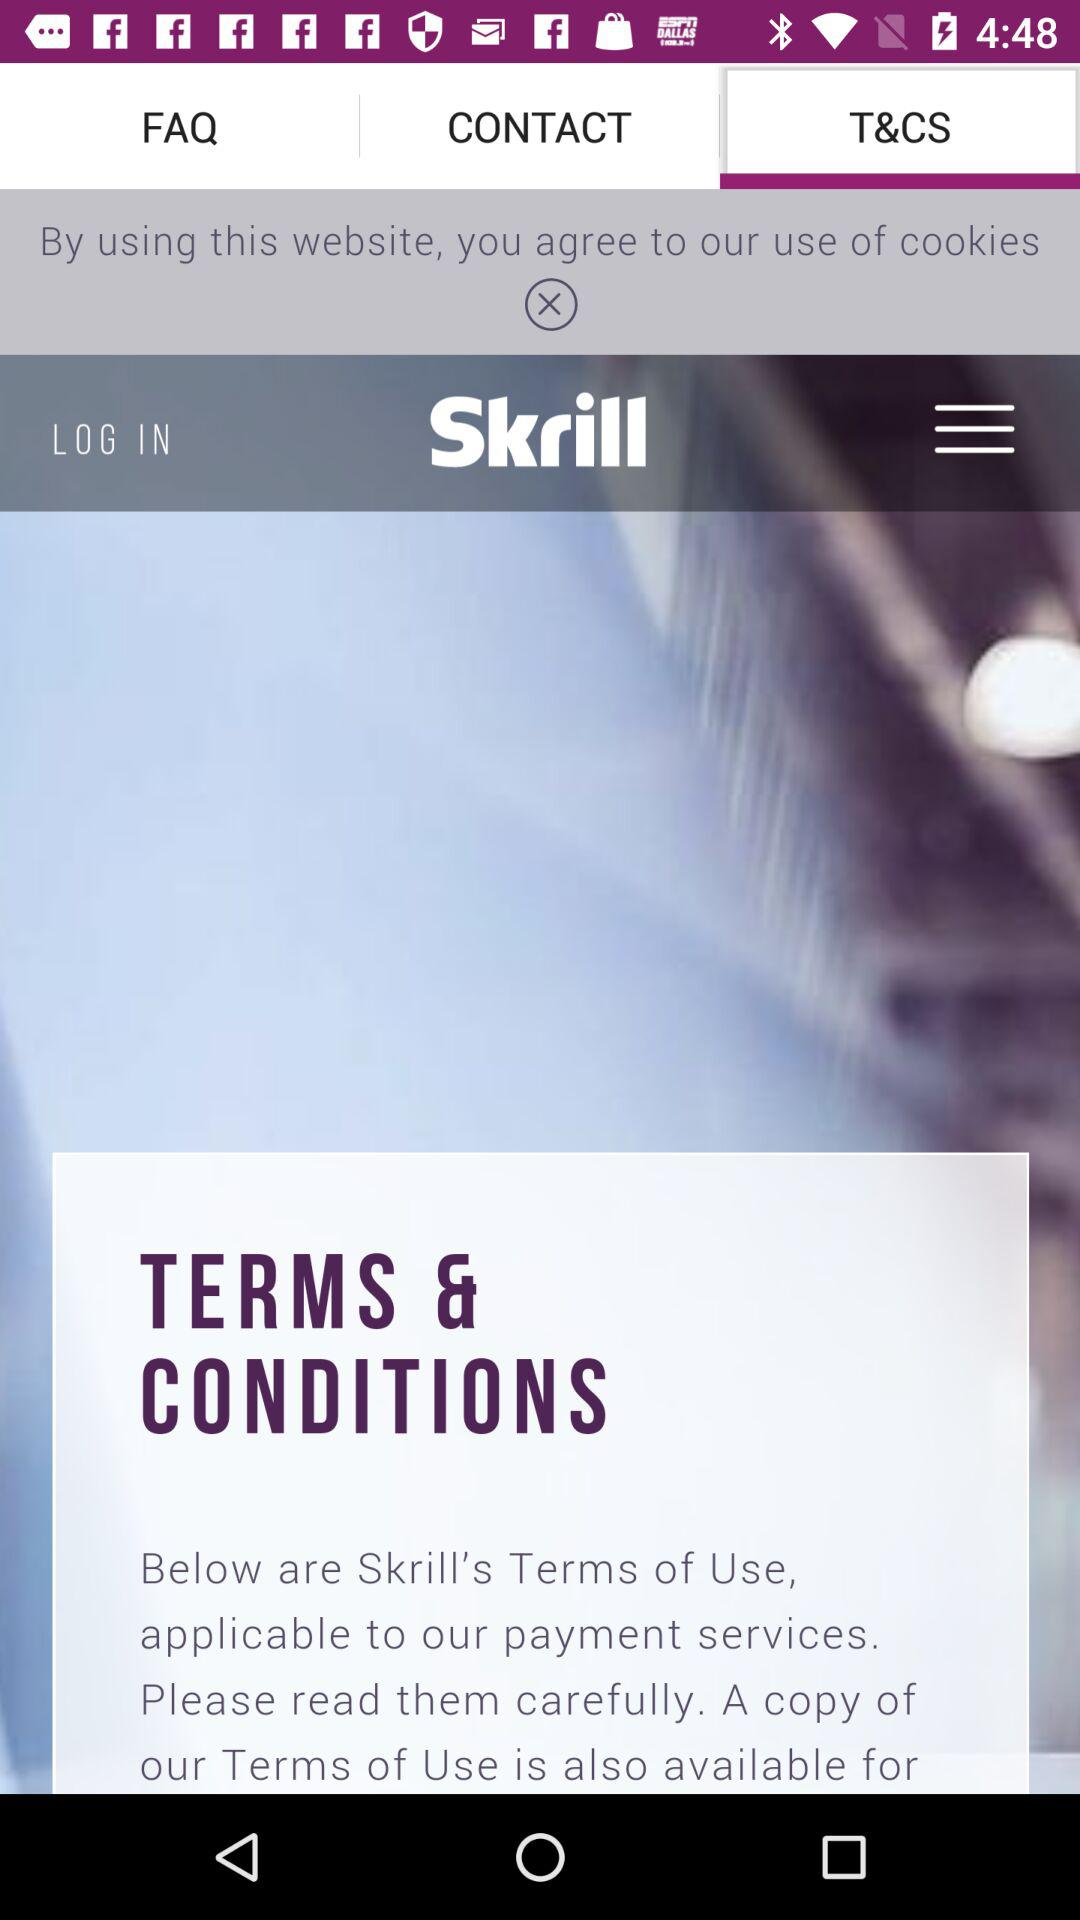Which tab is selected? The selected tab is "T&CS". 